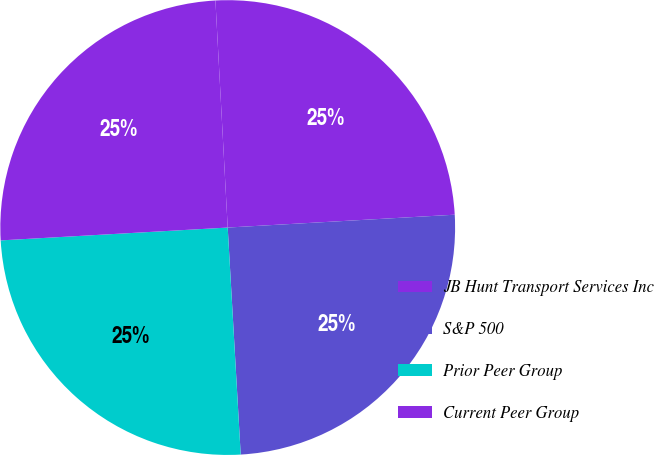<chart> <loc_0><loc_0><loc_500><loc_500><pie_chart><fcel>JB Hunt Transport Services Inc<fcel>S&P 500<fcel>Prior Peer Group<fcel>Current Peer Group<nl><fcel>24.96%<fcel>24.99%<fcel>25.01%<fcel>25.04%<nl></chart> 